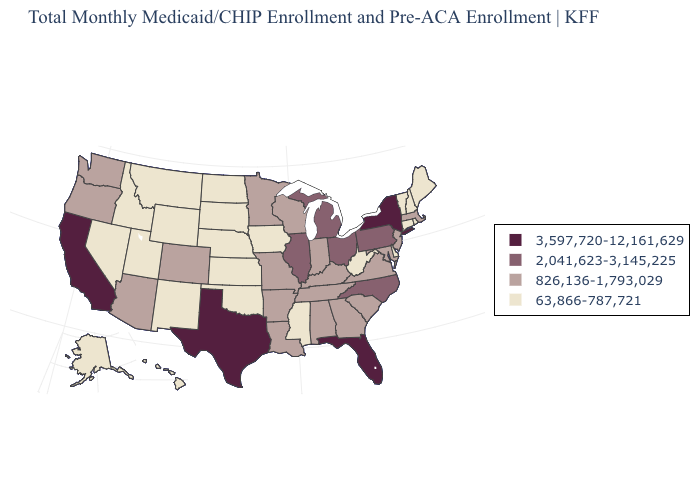What is the highest value in the MidWest ?
Answer briefly. 2,041,623-3,145,225. What is the value of Georgia?
Answer briefly. 826,136-1,793,029. Does California have the highest value in the USA?
Keep it brief. Yes. Does Indiana have a higher value than New Jersey?
Keep it brief. No. Is the legend a continuous bar?
Give a very brief answer. No. Does Nevada have the highest value in the USA?
Keep it brief. No. Name the states that have a value in the range 63,866-787,721?
Concise answer only. Alaska, Connecticut, Delaware, Hawaii, Idaho, Iowa, Kansas, Maine, Mississippi, Montana, Nebraska, Nevada, New Hampshire, New Mexico, North Dakota, Oklahoma, Rhode Island, South Dakota, Utah, Vermont, West Virginia, Wyoming. What is the highest value in the Northeast ?
Write a very short answer. 3,597,720-12,161,629. What is the lowest value in the USA?
Short answer required. 63,866-787,721. Among the states that border Nebraska , does Wyoming have the highest value?
Give a very brief answer. No. Name the states that have a value in the range 826,136-1,793,029?
Short answer required. Alabama, Arizona, Arkansas, Colorado, Georgia, Indiana, Kentucky, Louisiana, Maryland, Massachusetts, Minnesota, Missouri, New Jersey, Oregon, South Carolina, Tennessee, Virginia, Washington, Wisconsin. Name the states that have a value in the range 3,597,720-12,161,629?
Write a very short answer. California, Florida, New York, Texas. What is the value of Nevada?
Be succinct. 63,866-787,721. Name the states that have a value in the range 2,041,623-3,145,225?
Short answer required. Illinois, Michigan, North Carolina, Ohio, Pennsylvania. Which states hav the highest value in the Northeast?
Answer briefly. New York. 